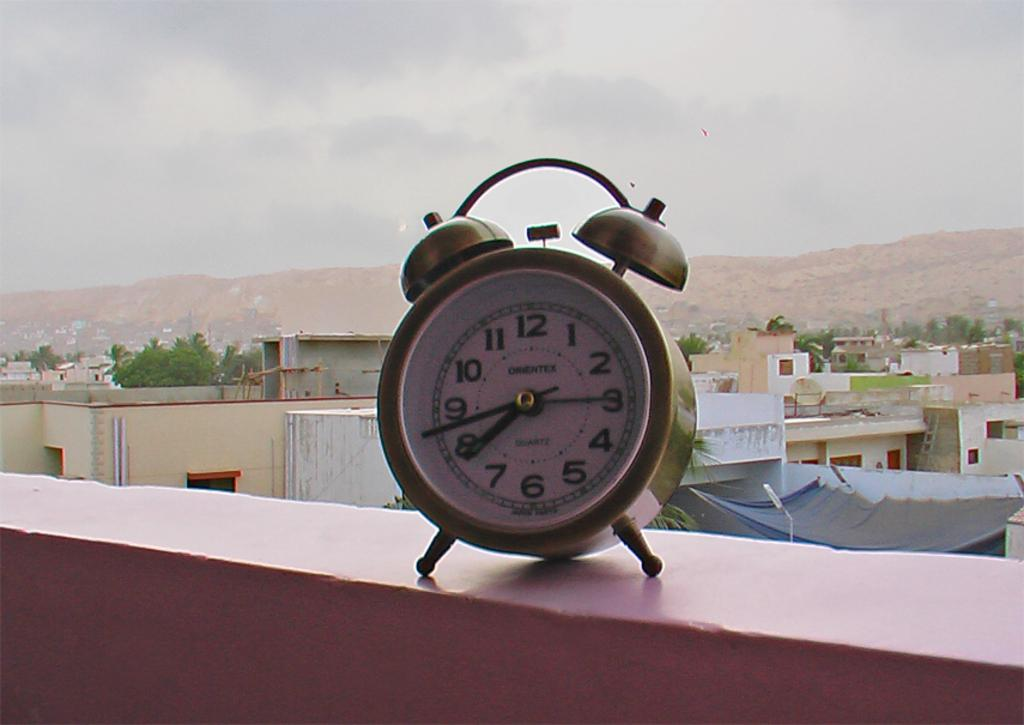<image>
Create a compact narrative representing the image presented. A gold Orientex clock is sitting on a ledge outside. 